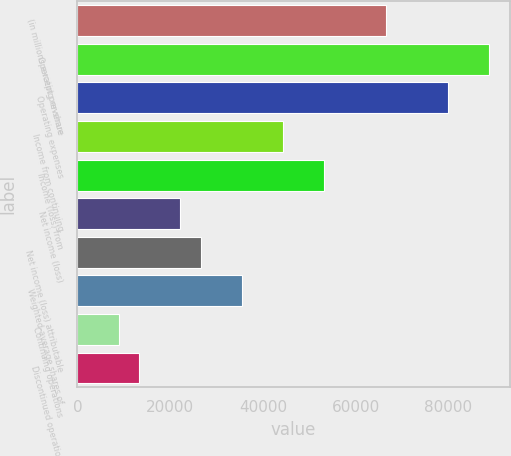Convert chart. <chart><loc_0><loc_0><loc_500><loc_500><bar_chart><fcel>(in millions except per-share<fcel>Operating revenue<fcel>Operating expenses<fcel>Income from continuing<fcel>Income (loss) from<fcel>Net income (loss)<fcel>Net income (loss) attributable<fcel>Weighted-average shares of<fcel>Continuing operations<fcel>Discontinued operations<nl><fcel>66590.7<fcel>88787.4<fcel>79908.7<fcel>44394<fcel>53272.6<fcel>22197.3<fcel>26636.6<fcel>35515.3<fcel>8879.24<fcel>13318.6<nl></chart> 